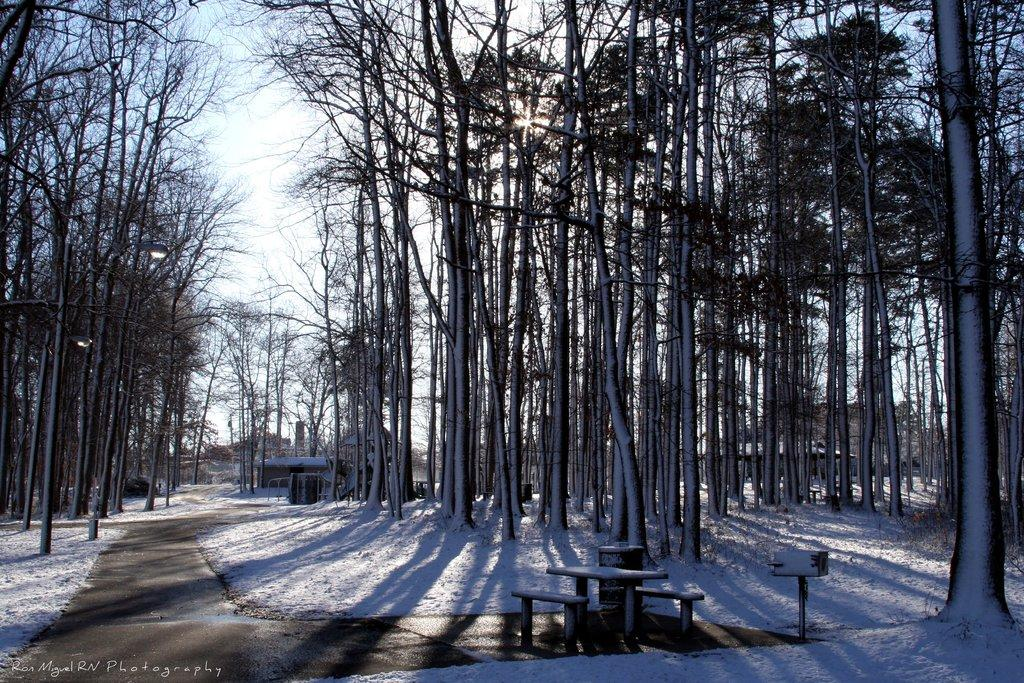What type of surface can be seen in the image? There is a road in the image. What is the weather like in the image? There is snow in the image, indicating a cold or wintery environment. What type of seating is available in the image? There are benches in the image. What type of vegetation is present in the image? There are trees in the image. What type of structure is visible in the image? There is a house in the image. What other objects can be seen in the image? There are some objects in the image, but their specific nature is not mentioned in the facts. What is visible in the background of the image? The sky is visible in the background of the image. What type of spark can be seen coming from the trees in the image? There is no spark present in the image; it features snow, a road, benches, trees, a house, and some objects, but no spark. What is the sister of the person in the image doing? There is no person mentioned in the image, so it is impossible to determine the actions of a sister. 